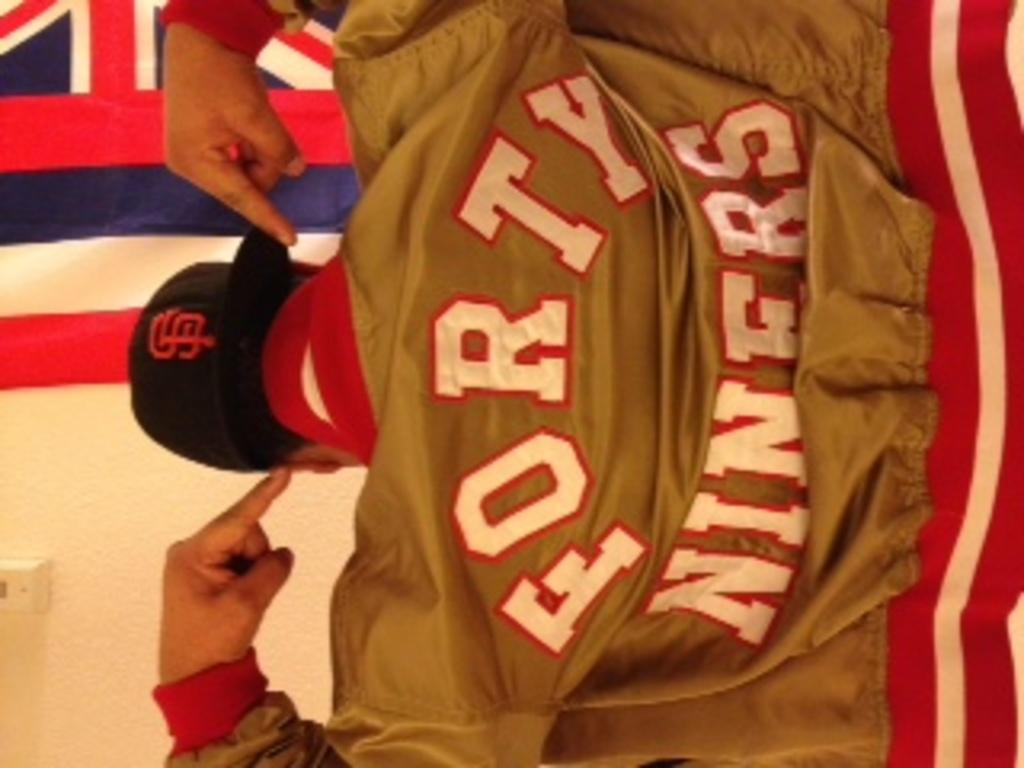<image>
Summarize the visual content of the image. A man is wearing a gold jacket that says "FORTY NINERS" on the back. 